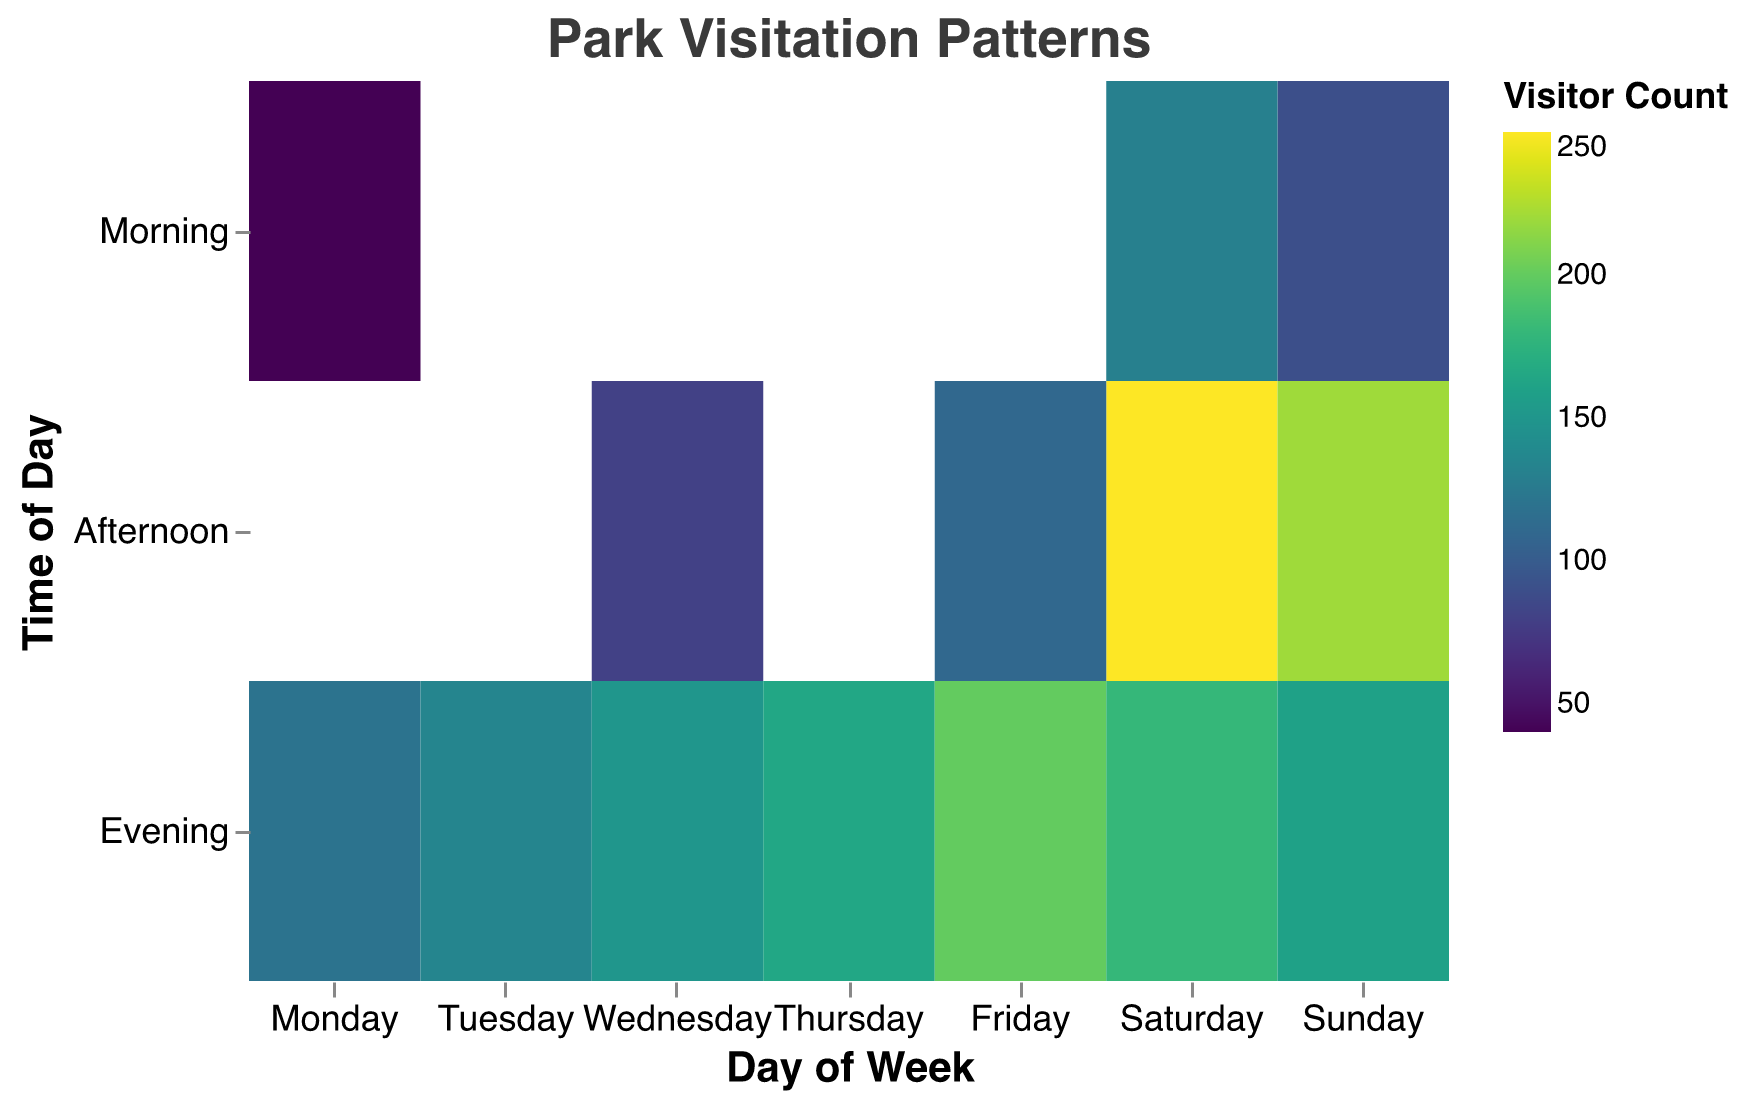What is the title of the figure? The title is usually positioned at the top of the figure and is clearly labeled in a larger font to describe what the plot represents.
Answer: Park Visitation Patterns On which day is the highest visitor count recorded? By looking at the color legend and the darkest color shades representing the highest visitor count, we can identify that Saturday Afternoon has the darkest shade indicating the highest count.
Answer: Saturday During which time of day is the park least often visited on Monday? By identifying the lightest color shade on Monday’s row among the three time periods (Morning, Afternoon, Evening), it is evident that Monday Morning has the lightest shade, indicating the lowest visitor count.
Answer: Morning What is the total visitor count for Sunday? Add up the visitor counts for Morning, Afternoon, and Evening on Sunday: 90 (morning) + 220 (afternoon) + 160 (evening) = 470.
Answer: 470 Which day has the most consistent park visitor counts across different times of day? To find the most consistent visitor counts, look for a day where the color shades are similar across Morning, Afternoon, and Evening. Sunday shows consistent darker shades (90, 220, 160) indicating more uniform visitor counts compared to other days.
Answer: Sunday What time of day gains the highest overall visitor counts? To determine this, compare the frequencies of dark shades in Morning, Afternoon, and Evening across all days. Afternoon generally has the most dark shades indicating higher visitor counts, especially on Saturday and Sunday.
Answer: Afternoon How does the visitor count on Wednesday Evening compare to Wednesday Afternoon? Compare the color shades for Wednesday Evening and Afternoon. Evening has a much darker shade (150) compared to Afternoon (80).
Answer: Evening has higher counts Is there any day where Morning has the highest visitor count for that day? To answer this, look at the darkest color shade in the Morning for each day and compare it to the other times of day. Saturday Morning has a relatively darker shade (130), but the Afternoon on Saturday has an even darker shade. Therefore, no day has Morning as the highest visitor count.
Answer: No Which two time periods of Saturday have the closest visitor counts? Look at the color shades for Morning, Afternoon, and Evening on Saturday. Morning (130) and Evening (180) have closer counts compared to Afternoon (250).
Answer: Morning and Evening Considering the entire week, which day has the most dynamic change in visitor count throughout the day? To find the most dynamic change, look for the day with the widest range of color shades between different times. Saturday shows a large variance from Morning (130) to Afternoon (250) and Evening (180), indicating the most dynamic change.
Answer: Saturday 